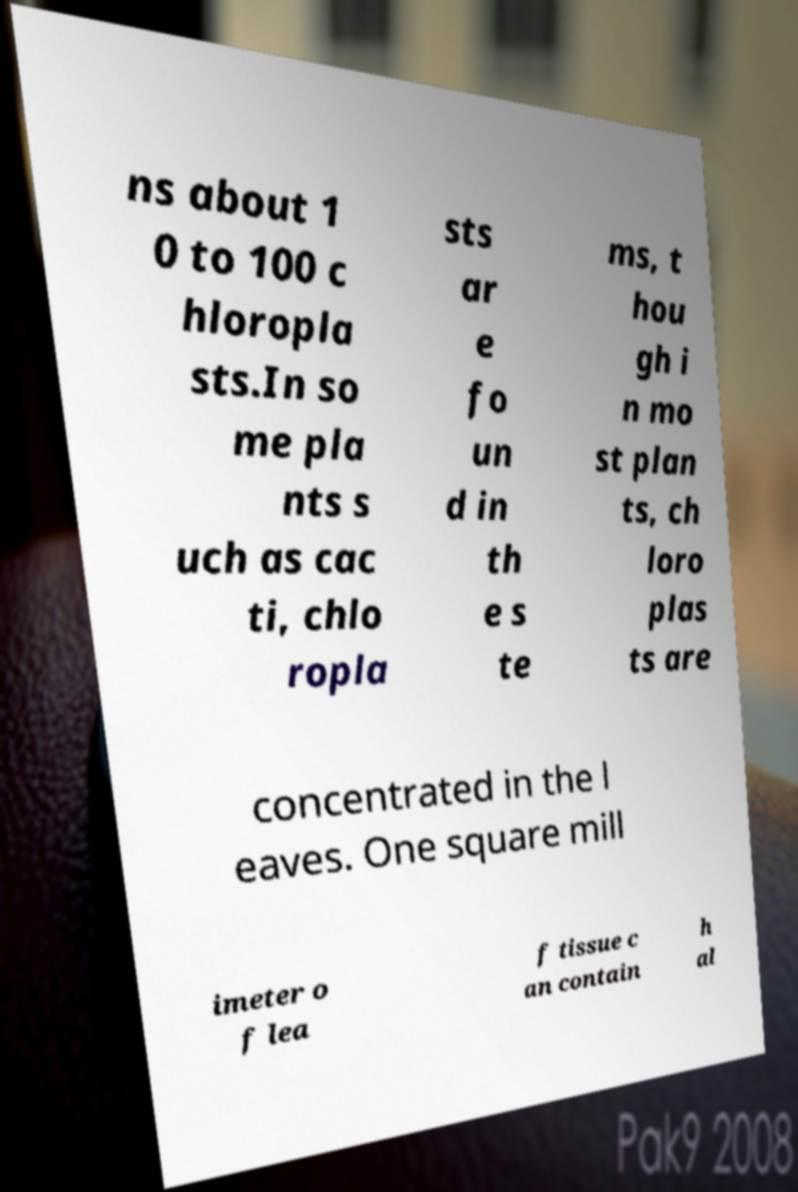Can you read and provide the text displayed in the image?This photo seems to have some interesting text. Can you extract and type it out for me? ns about 1 0 to 100 c hloropla sts.In so me pla nts s uch as cac ti, chlo ropla sts ar e fo un d in th e s te ms, t hou gh i n mo st plan ts, ch loro plas ts are concentrated in the l eaves. One square mill imeter o f lea f tissue c an contain h al 